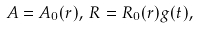Convert formula to latex. <formula><loc_0><loc_0><loc_500><loc_500>A = A _ { 0 } ( r ) , \, R = R _ { 0 } ( r ) g ( t ) ,</formula> 